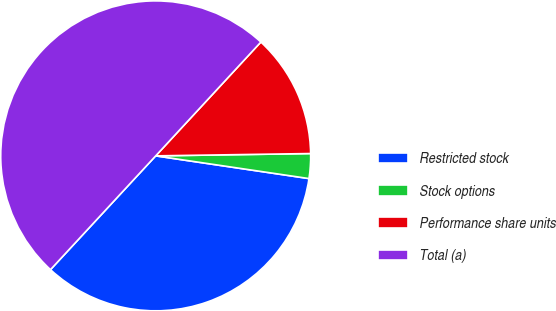Convert chart. <chart><loc_0><loc_0><loc_500><loc_500><pie_chart><fcel>Restricted stock<fcel>Stock options<fcel>Performance share units<fcel>Total (a)<nl><fcel>34.54%<fcel>2.58%<fcel>12.89%<fcel>50.0%<nl></chart> 